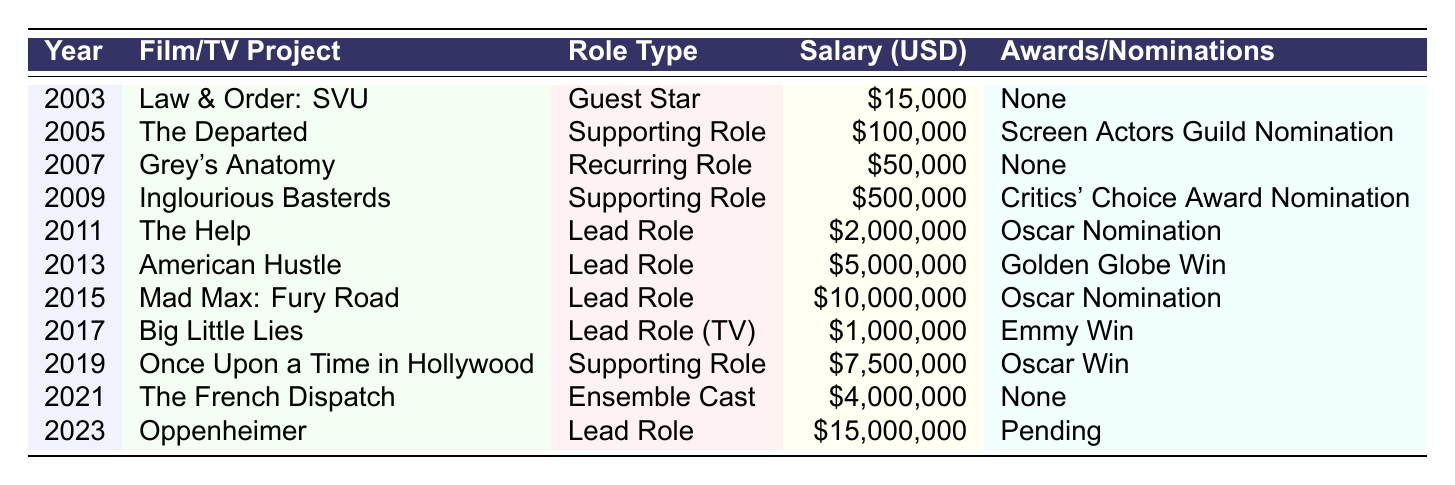What was the highest salary earned in a single year? The salary with the highest value in the table is from the year 2023, which is $15,000,000 for the role in "Oppenheimer."
Answer: $15,000,000 In what year did the actor first receive an Oscar nomination? The first Oscar nomination noted in the table is from the year 2011 for the film "The Help."
Answer: 2011 What is the total salary earned over the 20 years? To calculate the total salary, we sum all the yearly salaries: $15,000 + $100,000 + $50,000 + $500,000 + $2,000,000 + $5,000,000 + $10,000,000 + $1,000,000 + $7,500,000 + $4,000,000 + $15,000,000 = $45,165,000.
Answer: $45,165,000 How many projects had awards or nominations associated with them? The projects with awards or nominations are counted: "The Departed," "Inglourious Basterds," "The Help," "American Hustle," "Mad Max: Fury Road," "Big Little Lies," "Once Upon a Time in Hollywood," and "Oppenheimer," which totals to 8.
Answer: 8 What type of role was played in the highest salary earner year? In 2023, the role was a "Lead Role" in "Oppenheimer."
Answer: Lead Role Was there any year the actor did not earn any awards or nominations? Yes, in the years 2003, 2007, and 2021, there were no awards or nominations associated with the projects.
Answer: Yes What was the average salary over the 20 years? To find the average, take the total calculated earlier ($45,165,000) and divide it by the number of years (11): $45,165,000 / 11 = $4,096,818.18.
Answer: $4,096,818.18 In which years did the actor play a lead role, and what was the associated salary? The actor held Lead Roles in 2011 ($2,000,000), 2013 ($5,000,000), 2015 ($10,000,000), and 2023 ($15,000,000).
Answer: 2011 ($2,000,000), 2013 ($5,000,000), 2015 ($10,000,000), 2023 ($15,000,000) What percentage of the total salary did the 2015 project contribute? The salary from 2015 was $10,000,000. To find the percentage: ($10,000,000 / $45,165,000) * 100 ≈ 22.14%.
Answer: 22.14% In how many years was the actor involved in a supporting role? The years with supporting roles include 2005 ("The Departed"), 2009 ("Inglourious Basterds"), and 2019 ("Once Upon a Time in Hollywood"), totaling 3 years.
Answer: 3 